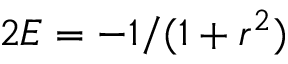Convert formula to latex. <formula><loc_0><loc_0><loc_500><loc_500>2 E = - 1 / ( 1 + r ^ { 2 } )</formula> 